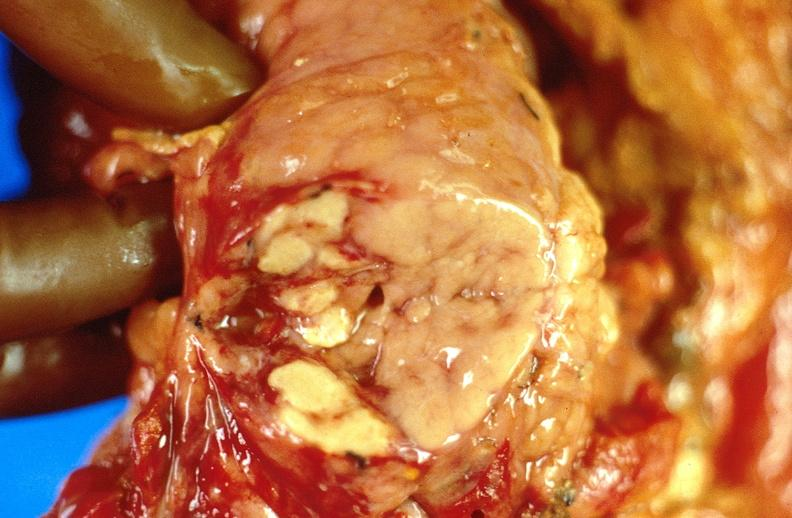does this image show pancreatic fat necrosis, pancreatitis?
Answer the question using a single word or phrase. Yes 